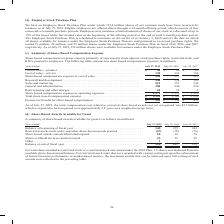According to Cisco Systems's financial document, What was the total compensation cost related to unvested share-based awards not yet recognized as of 2019? According to the financial document, $3.3 billion. The relevant text states: "unvested share-based awards not yet recognized was $3.3 billion, which is expected to be recognized over approximately 2.8 years on a weighted-average basis...." Also, What does share-based compensation expense consist of? primarily of expenses for stock options, stock purchase rights, restricted stock, and RSUs granted to employees.. The document states: "Share-based compensation expense consists primarily of expenses for stock options, stock purchase rights, restricted stock, and RSUs granted to employ..." Also, Which years does the table provide information for the company's share-based compensation expenses? The document contains multiple relevant values: 2019, 2018, 2017. From the document: "Years Ended July 27, 2019 July 28, 2018 July 29, 2017 Cost of sales—product . $ 90 $ 94 $ 85 Cost of sales—service . 130 133 134 Share-based compensat..." Also, can you calculate: What was the change in the product cost of sales between 2017 and 2018? Based on the calculation: 94-85, the result is 9 (in millions). This is based on the information: "2018 July 29, 2017 Cost of sales—product . $ 90 $ 94 $ 85 Cost of sales—service . 130 133 134 Share-based compensation expense in cost of sales . 220 22 July 29, 2017 Cost of sales—product . $ 90 $ 94..." The key data points involved are: 85, 94. Also, can you calculate: What was the total change in research and development between 2017 and 2019? Based on the calculation: 540-529, the result is 11 (in millions). This is based on the information: "of sales . 220 227 219 Research and development . 540 538 529 Sales and marketing . 519 555 542 General and administrative . 250 246 236 Restructuring an . 220 227 219 Research and development . 540 5..." The key data points involved are: 529, 540. Also, can you calculate: What was the percentage change in Total share-based compensation expense between 2018 and 2019? To answer this question, I need to perform calculations using the financial data. The calculation is: (1,591-1,599)/1,599, which equals -0.5 (percentage). This is based on the information: "otal share-based compensation expense . $ 1,591 $ 1,599 $ 1,529 Income tax benefit for share-based compensation . $ 542 $ 558 $ 451 1,310 Total share-based compensation expense . $ 1,591 $ 1,599 $ 1,5..." The key data points involved are: 1,591, 1,599. 